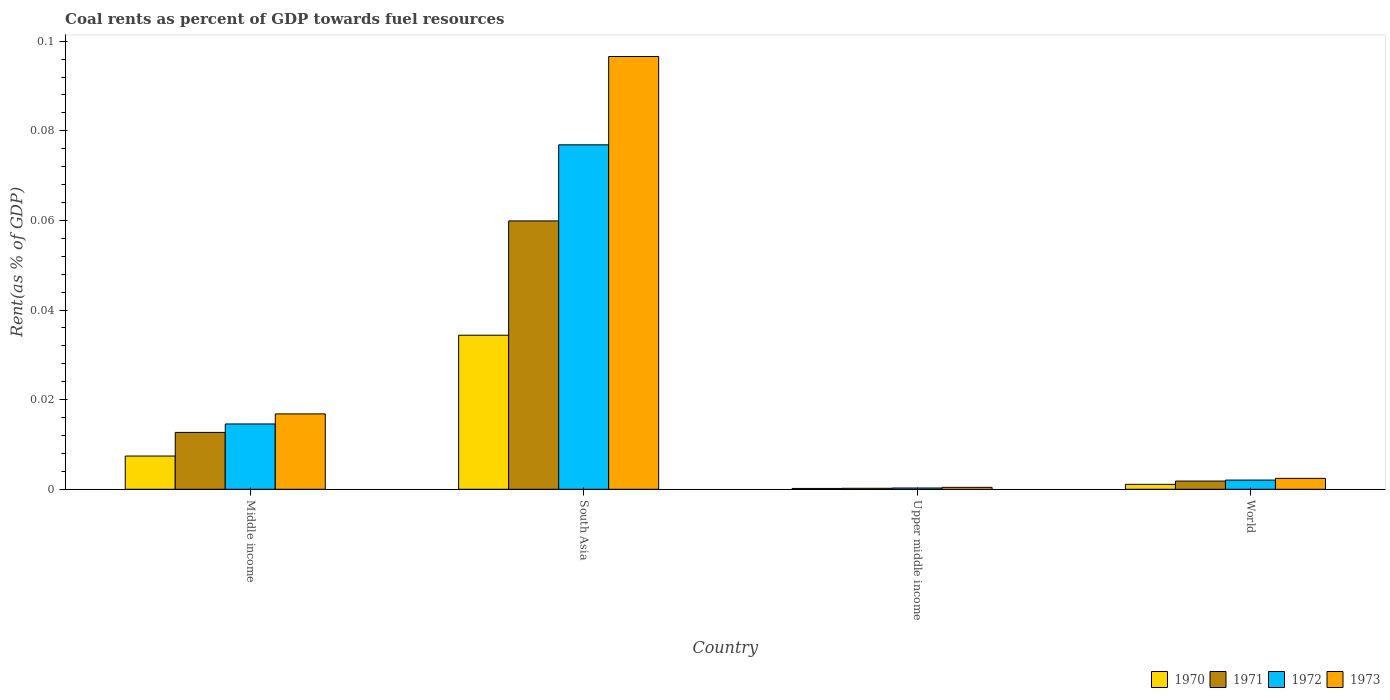How many different coloured bars are there?
Your answer should be compact. 4. Are the number of bars per tick equal to the number of legend labels?
Keep it short and to the point. Yes. In how many cases, is the number of bars for a given country not equal to the number of legend labels?
Your answer should be compact. 0. What is the coal rent in 1970 in South Asia?
Give a very brief answer. 0.03. Across all countries, what is the maximum coal rent in 1973?
Offer a terse response. 0.1. Across all countries, what is the minimum coal rent in 1973?
Your answer should be compact. 0. In which country was the coal rent in 1970 minimum?
Offer a terse response. Upper middle income. What is the total coal rent in 1971 in the graph?
Provide a succinct answer. 0.07. What is the difference between the coal rent in 1973 in South Asia and that in Upper middle income?
Ensure brevity in your answer.  0.1. What is the difference between the coal rent in 1971 in Upper middle income and the coal rent in 1970 in South Asia?
Keep it short and to the point. -0.03. What is the average coal rent in 1970 per country?
Offer a terse response. 0.01. What is the difference between the coal rent of/in 1970 and coal rent of/in 1972 in South Asia?
Provide a short and direct response. -0.04. What is the ratio of the coal rent in 1971 in Middle income to that in World?
Offer a terse response. 6.93. Is the difference between the coal rent in 1970 in South Asia and Upper middle income greater than the difference between the coal rent in 1972 in South Asia and Upper middle income?
Give a very brief answer. No. What is the difference between the highest and the second highest coal rent in 1972?
Give a very brief answer. 0.07. What is the difference between the highest and the lowest coal rent in 1970?
Your answer should be very brief. 0.03. What does the 1st bar from the left in Middle income represents?
Your answer should be very brief. 1970. What does the 3rd bar from the right in South Asia represents?
Give a very brief answer. 1971. Is it the case that in every country, the sum of the coal rent in 1971 and coal rent in 1972 is greater than the coal rent in 1970?
Offer a very short reply. Yes. How many bars are there?
Provide a succinct answer. 16. How many countries are there in the graph?
Give a very brief answer. 4. What is the difference between two consecutive major ticks on the Y-axis?
Offer a terse response. 0.02. Does the graph contain grids?
Ensure brevity in your answer.  No. Where does the legend appear in the graph?
Offer a very short reply. Bottom right. How are the legend labels stacked?
Your answer should be very brief. Horizontal. What is the title of the graph?
Offer a very short reply. Coal rents as percent of GDP towards fuel resources. Does "1971" appear as one of the legend labels in the graph?
Make the answer very short. Yes. What is the label or title of the Y-axis?
Keep it short and to the point. Rent(as % of GDP). What is the Rent(as % of GDP) of 1970 in Middle income?
Ensure brevity in your answer.  0.01. What is the Rent(as % of GDP) in 1971 in Middle income?
Make the answer very short. 0.01. What is the Rent(as % of GDP) of 1972 in Middle income?
Give a very brief answer. 0.01. What is the Rent(as % of GDP) in 1973 in Middle income?
Give a very brief answer. 0.02. What is the Rent(as % of GDP) of 1970 in South Asia?
Provide a short and direct response. 0.03. What is the Rent(as % of GDP) of 1971 in South Asia?
Offer a terse response. 0.06. What is the Rent(as % of GDP) in 1972 in South Asia?
Give a very brief answer. 0.08. What is the Rent(as % of GDP) of 1973 in South Asia?
Make the answer very short. 0.1. What is the Rent(as % of GDP) in 1970 in Upper middle income?
Your response must be concise. 0. What is the Rent(as % of GDP) of 1971 in Upper middle income?
Provide a short and direct response. 0. What is the Rent(as % of GDP) of 1972 in Upper middle income?
Provide a succinct answer. 0. What is the Rent(as % of GDP) in 1973 in Upper middle income?
Your answer should be very brief. 0. What is the Rent(as % of GDP) in 1970 in World?
Ensure brevity in your answer.  0. What is the Rent(as % of GDP) in 1971 in World?
Your answer should be very brief. 0. What is the Rent(as % of GDP) in 1972 in World?
Your response must be concise. 0. What is the Rent(as % of GDP) of 1973 in World?
Offer a very short reply. 0. Across all countries, what is the maximum Rent(as % of GDP) in 1970?
Give a very brief answer. 0.03. Across all countries, what is the maximum Rent(as % of GDP) in 1971?
Provide a short and direct response. 0.06. Across all countries, what is the maximum Rent(as % of GDP) of 1972?
Make the answer very short. 0.08. Across all countries, what is the maximum Rent(as % of GDP) in 1973?
Your answer should be compact. 0.1. Across all countries, what is the minimum Rent(as % of GDP) in 1970?
Offer a terse response. 0. Across all countries, what is the minimum Rent(as % of GDP) in 1971?
Your answer should be compact. 0. Across all countries, what is the minimum Rent(as % of GDP) in 1972?
Make the answer very short. 0. Across all countries, what is the minimum Rent(as % of GDP) in 1973?
Keep it short and to the point. 0. What is the total Rent(as % of GDP) in 1970 in the graph?
Provide a succinct answer. 0.04. What is the total Rent(as % of GDP) of 1971 in the graph?
Offer a terse response. 0.07. What is the total Rent(as % of GDP) of 1972 in the graph?
Offer a very short reply. 0.09. What is the total Rent(as % of GDP) of 1973 in the graph?
Offer a very short reply. 0.12. What is the difference between the Rent(as % of GDP) in 1970 in Middle income and that in South Asia?
Keep it short and to the point. -0.03. What is the difference between the Rent(as % of GDP) in 1971 in Middle income and that in South Asia?
Provide a succinct answer. -0.05. What is the difference between the Rent(as % of GDP) in 1972 in Middle income and that in South Asia?
Your answer should be compact. -0.06. What is the difference between the Rent(as % of GDP) of 1973 in Middle income and that in South Asia?
Keep it short and to the point. -0.08. What is the difference between the Rent(as % of GDP) in 1970 in Middle income and that in Upper middle income?
Your answer should be very brief. 0.01. What is the difference between the Rent(as % of GDP) of 1971 in Middle income and that in Upper middle income?
Your response must be concise. 0.01. What is the difference between the Rent(as % of GDP) in 1972 in Middle income and that in Upper middle income?
Make the answer very short. 0.01. What is the difference between the Rent(as % of GDP) in 1973 in Middle income and that in Upper middle income?
Provide a short and direct response. 0.02. What is the difference between the Rent(as % of GDP) in 1970 in Middle income and that in World?
Your response must be concise. 0.01. What is the difference between the Rent(as % of GDP) of 1971 in Middle income and that in World?
Your answer should be very brief. 0.01. What is the difference between the Rent(as % of GDP) of 1972 in Middle income and that in World?
Provide a short and direct response. 0.01. What is the difference between the Rent(as % of GDP) of 1973 in Middle income and that in World?
Give a very brief answer. 0.01. What is the difference between the Rent(as % of GDP) of 1970 in South Asia and that in Upper middle income?
Your answer should be compact. 0.03. What is the difference between the Rent(as % of GDP) of 1971 in South Asia and that in Upper middle income?
Make the answer very short. 0.06. What is the difference between the Rent(as % of GDP) of 1972 in South Asia and that in Upper middle income?
Provide a short and direct response. 0.08. What is the difference between the Rent(as % of GDP) of 1973 in South Asia and that in Upper middle income?
Your answer should be very brief. 0.1. What is the difference between the Rent(as % of GDP) in 1970 in South Asia and that in World?
Keep it short and to the point. 0.03. What is the difference between the Rent(as % of GDP) of 1971 in South Asia and that in World?
Offer a terse response. 0.06. What is the difference between the Rent(as % of GDP) in 1972 in South Asia and that in World?
Make the answer very short. 0.07. What is the difference between the Rent(as % of GDP) of 1973 in South Asia and that in World?
Keep it short and to the point. 0.09. What is the difference between the Rent(as % of GDP) of 1970 in Upper middle income and that in World?
Offer a terse response. -0. What is the difference between the Rent(as % of GDP) of 1971 in Upper middle income and that in World?
Your answer should be compact. -0. What is the difference between the Rent(as % of GDP) in 1972 in Upper middle income and that in World?
Make the answer very short. -0. What is the difference between the Rent(as % of GDP) of 1973 in Upper middle income and that in World?
Give a very brief answer. -0. What is the difference between the Rent(as % of GDP) in 1970 in Middle income and the Rent(as % of GDP) in 1971 in South Asia?
Provide a short and direct response. -0.05. What is the difference between the Rent(as % of GDP) of 1970 in Middle income and the Rent(as % of GDP) of 1972 in South Asia?
Provide a succinct answer. -0.07. What is the difference between the Rent(as % of GDP) of 1970 in Middle income and the Rent(as % of GDP) of 1973 in South Asia?
Provide a short and direct response. -0.09. What is the difference between the Rent(as % of GDP) of 1971 in Middle income and the Rent(as % of GDP) of 1972 in South Asia?
Your answer should be very brief. -0.06. What is the difference between the Rent(as % of GDP) of 1971 in Middle income and the Rent(as % of GDP) of 1973 in South Asia?
Offer a terse response. -0.08. What is the difference between the Rent(as % of GDP) of 1972 in Middle income and the Rent(as % of GDP) of 1973 in South Asia?
Offer a very short reply. -0.08. What is the difference between the Rent(as % of GDP) in 1970 in Middle income and the Rent(as % of GDP) in 1971 in Upper middle income?
Provide a short and direct response. 0.01. What is the difference between the Rent(as % of GDP) in 1970 in Middle income and the Rent(as % of GDP) in 1972 in Upper middle income?
Provide a succinct answer. 0.01. What is the difference between the Rent(as % of GDP) of 1970 in Middle income and the Rent(as % of GDP) of 1973 in Upper middle income?
Offer a terse response. 0.01. What is the difference between the Rent(as % of GDP) in 1971 in Middle income and the Rent(as % of GDP) in 1972 in Upper middle income?
Make the answer very short. 0.01. What is the difference between the Rent(as % of GDP) of 1971 in Middle income and the Rent(as % of GDP) of 1973 in Upper middle income?
Give a very brief answer. 0.01. What is the difference between the Rent(as % of GDP) in 1972 in Middle income and the Rent(as % of GDP) in 1973 in Upper middle income?
Offer a very short reply. 0.01. What is the difference between the Rent(as % of GDP) in 1970 in Middle income and the Rent(as % of GDP) in 1971 in World?
Give a very brief answer. 0.01. What is the difference between the Rent(as % of GDP) in 1970 in Middle income and the Rent(as % of GDP) in 1972 in World?
Make the answer very short. 0.01. What is the difference between the Rent(as % of GDP) of 1970 in Middle income and the Rent(as % of GDP) of 1973 in World?
Your response must be concise. 0.01. What is the difference between the Rent(as % of GDP) in 1971 in Middle income and the Rent(as % of GDP) in 1972 in World?
Provide a succinct answer. 0.01. What is the difference between the Rent(as % of GDP) of 1971 in Middle income and the Rent(as % of GDP) of 1973 in World?
Provide a succinct answer. 0.01. What is the difference between the Rent(as % of GDP) in 1972 in Middle income and the Rent(as % of GDP) in 1973 in World?
Offer a terse response. 0.01. What is the difference between the Rent(as % of GDP) in 1970 in South Asia and the Rent(as % of GDP) in 1971 in Upper middle income?
Make the answer very short. 0.03. What is the difference between the Rent(as % of GDP) of 1970 in South Asia and the Rent(as % of GDP) of 1972 in Upper middle income?
Provide a succinct answer. 0.03. What is the difference between the Rent(as % of GDP) of 1970 in South Asia and the Rent(as % of GDP) of 1973 in Upper middle income?
Make the answer very short. 0.03. What is the difference between the Rent(as % of GDP) in 1971 in South Asia and the Rent(as % of GDP) in 1972 in Upper middle income?
Your answer should be very brief. 0.06. What is the difference between the Rent(as % of GDP) in 1971 in South Asia and the Rent(as % of GDP) in 1973 in Upper middle income?
Offer a terse response. 0.06. What is the difference between the Rent(as % of GDP) of 1972 in South Asia and the Rent(as % of GDP) of 1973 in Upper middle income?
Your response must be concise. 0.08. What is the difference between the Rent(as % of GDP) in 1970 in South Asia and the Rent(as % of GDP) in 1971 in World?
Offer a terse response. 0.03. What is the difference between the Rent(as % of GDP) in 1970 in South Asia and the Rent(as % of GDP) in 1972 in World?
Offer a terse response. 0.03. What is the difference between the Rent(as % of GDP) of 1970 in South Asia and the Rent(as % of GDP) of 1973 in World?
Offer a terse response. 0.03. What is the difference between the Rent(as % of GDP) in 1971 in South Asia and the Rent(as % of GDP) in 1972 in World?
Offer a very short reply. 0.06. What is the difference between the Rent(as % of GDP) in 1971 in South Asia and the Rent(as % of GDP) in 1973 in World?
Provide a short and direct response. 0.06. What is the difference between the Rent(as % of GDP) in 1972 in South Asia and the Rent(as % of GDP) in 1973 in World?
Offer a very short reply. 0.07. What is the difference between the Rent(as % of GDP) in 1970 in Upper middle income and the Rent(as % of GDP) in 1971 in World?
Offer a very short reply. -0. What is the difference between the Rent(as % of GDP) in 1970 in Upper middle income and the Rent(as % of GDP) in 1972 in World?
Give a very brief answer. -0. What is the difference between the Rent(as % of GDP) of 1970 in Upper middle income and the Rent(as % of GDP) of 1973 in World?
Provide a short and direct response. -0. What is the difference between the Rent(as % of GDP) of 1971 in Upper middle income and the Rent(as % of GDP) of 1972 in World?
Give a very brief answer. -0. What is the difference between the Rent(as % of GDP) of 1971 in Upper middle income and the Rent(as % of GDP) of 1973 in World?
Give a very brief answer. -0. What is the difference between the Rent(as % of GDP) of 1972 in Upper middle income and the Rent(as % of GDP) of 1973 in World?
Offer a very short reply. -0. What is the average Rent(as % of GDP) of 1970 per country?
Your answer should be very brief. 0.01. What is the average Rent(as % of GDP) in 1971 per country?
Offer a terse response. 0.02. What is the average Rent(as % of GDP) in 1972 per country?
Provide a short and direct response. 0.02. What is the average Rent(as % of GDP) of 1973 per country?
Ensure brevity in your answer.  0.03. What is the difference between the Rent(as % of GDP) in 1970 and Rent(as % of GDP) in 1971 in Middle income?
Ensure brevity in your answer.  -0.01. What is the difference between the Rent(as % of GDP) in 1970 and Rent(as % of GDP) in 1972 in Middle income?
Provide a succinct answer. -0.01. What is the difference between the Rent(as % of GDP) in 1970 and Rent(as % of GDP) in 1973 in Middle income?
Provide a succinct answer. -0.01. What is the difference between the Rent(as % of GDP) in 1971 and Rent(as % of GDP) in 1972 in Middle income?
Keep it short and to the point. -0. What is the difference between the Rent(as % of GDP) in 1971 and Rent(as % of GDP) in 1973 in Middle income?
Give a very brief answer. -0. What is the difference between the Rent(as % of GDP) of 1972 and Rent(as % of GDP) of 1973 in Middle income?
Your response must be concise. -0. What is the difference between the Rent(as % of GDP) of 1970 and Rent(as % of GDP) of 1971 in South Asia?
Your response must be concise. -0.03. What is the difference between the Rent(as % of GDP) of 1970 and Rent(as % of GDP) of 1972 in South Asia?
Your answer should be very brief. -0.04. What is the difference between the Rent(as % of GDP) of 1970 and Rent(as % of GDP) of 1973 in South Asia?
Keep it short and to the point. -0.06. What is the difference between the Rent(as % of GDP) of 1971 and Rent(as % of GDP) of 1972 in South Asia?
Ensure brevity in your answer.  -0.02. What is the difference between the Rent(as % of GDP) in 1971 and Rent(as % of GDP) in 1973 in South Asia?
Your answer should be very brief. -0.04. What is the difference between the Rent(as % of GDP) in 1972 and Rent(as % of GDP) in 1973 in South Asia?
Keep it short and to the point. -0.02. What is the difference between the Rent(as % of GDP) in 1970 and Rent(as % of GDP) in 1971 in Upper middle income?
Give a very brief answer. -0. What is the difference between the Rent(as % of GDP) in 1970 and Rent(as % of GDP) in 1972 in Upper middle income?
Keep it short and to the point. -0. What is the difference between the Rent(as % of GDP) in 1970 and Rent(as % of GDP) in 1973 in Upper middle income?
Give a very brief answer. -0. What is the difference between the Rent(as % of GDP) in 1971 and Rent(as % of GDP) in 1972 in Upper middle income?
Keep it short and to the point. -0. What is the difference between the Rent(as % of GDP) of 1971 and Rent(as % of GDP) of 1973 in Upper middle income?
Your answer should be very brief. -0. What is the difference between the Rent(as % of GDP) of 1972 and Rent(as % of GDP) of 1973 in Upper middle income?
Ensure brevity in your answer.  -0. What is the difference between the Rent(as % of GDP) of 1970 and Rent(as % of GDP) of 1971 in World?
Offer a very short reply. -0. What is the difference between the Rent(as % of GDP) of 1970 and Rent(as % of GDP) of 1972 in World?
Provide a short and direct response. -0. What is the difference between the Rent(as % of GDP) of 1970 and Rent(as % of GDP) of 1973 in World?
Your response must be concise. -0. What is the difference between the Rent(as % of GDP) in 1971 and Rent(as % of GDP) in 1972 in World?
Your response must be concise. -0. What is the difference between the Rent(as % of GDP) of 1971 and Rent(as % of GDP) of 1973 in World?
Offer a terse response. -0. What is the difference between the Rent(as % of GDP) of 1972 and Rent(as % of GDP) of 1973 in World?
Your answer should be very brief. -0. What is the ratio of the Rent(as % of GDP) in 1970 in Middle income to that in South Asia?
Your response must be concise. 0.22. What is the ratio of the Rent(as % of GDP) in 1971 in Middle income to that in South Asia?
Provide a short and direct response. 0.21. What is the ratio of the Rent(as % of GDP) in 1972 in Middle income to that in South Asia?
Your response must be concise. 0.19. What is the ratio of the Rent(as % of GDP) in 1973 in Middle income to that in South Asia?
Ensure brevity in your answer.  0.17. What is the ratio of the Rent(as % of GDP) in 1970 in Middle income to that in Upper middle income?
Keep it short and to the point. 40.36. What is the ratio of the Rent(as % of GDP) in 1971 in Middle income to that in Upper middle income?
Offer a terse response. 58.01. What is the ratio of the Rent(as % of GDP) of 1972 in Middle income to that in Upper middle income?
Make the answer very short. 51.25. What is the ratio of the Rent(as % of GDP) of 1973 in Middle income to that in Upper middle income?
Your answer should be compact. 39.04. What is the ratio of the Rent(as % of GDP) in 1970 in Middle income to that in World?
Ensure brevity in your answer.  6.74. What is the ratio of the Rent(as % of GDP) of 1971 in Middle income to that in World?
Your response must be concise. 6.93. What is the ratio of the Rent(as % of GDP) of 1972 in Middle income to that in World?
Give a very brief answer. 7.09. What is the ratio of the Rent(as % of GDP) in 1973 in Middle income to that in World?
Offer a very short reply. 6.91. What is the ratio of the Rent(as % of GDP) of 1970 in South Asia to that in Upper middle income?
Keep it short and to the point. 187.05. What is the ratio of the Rent(as % of GDP) in 1971 in South Asia to that in Upper middle income?
Your answer should be very brief. 273.74. What is the ratio of the Rent(as % of GDP) in 1972 in South Asia to that in Upper middle income?
Provide a short and direct response. 270.32. What is the ratio of the Rent(as % of GDP) in 1973 in South Asia to that in Upper middle income?
Offer a very short reply. 224.18. What is the ratio of the Rent(as % of GDP) in 1970 in South Asia to that in World?
Keep it short and to the point. 31.24. What is the ratio of the Rent(as % of GDP) of 1971 in South Asia to that in World?
Give a very brief answer. 32.69. What is the ratio of the Rent(as % of GDP) in 1972 in South Asia to that in World?
Offer a terse response. 37.41. What is the ratio of the Rent(as % of GDP) of 1973 in South Asia to that in World?
Provide a short and direct response. 39.65. What is the ratio of the Rent(as % of GDP) of 1970 in Upper middle income to that in World?
Make the answer very short. 0.17. What is the ratio of the Rent(as % of GDP) in 1971 in Upper middle income to that in World?
Offer a terse response. 0.12. What is the ratio of the Rent(as % of GDP) in 1972 in Upper middle income to that in World?
Keep it short and to the point. 0.14. What is the ratio of the Rent(as % of GDP) of 1973 in Upper middle income to that in World?
Provide a short and direct response. 0.18. What is the difference between the highest and the second highest Rent(as % of GDP) of 1970?
Your answer should be very brief. 0.03. What is the difference between the highest and the second highest Rent(as % of GDP) in 1971?
Give a very brief answer. 0.05. What is the difference between the highest and the second highest Rent(as % of GDP) in 1972?
Ensure brevity in your answer.  0.06. What is the difference between the highest and the second highest Rent(as % of GDP) of 1973?
Your response must be concise. 0.08. What is the difference between the highest and the lowest Rent(as % of GDP) of 1970?
Provide a succinct answer. 0.03. What is the difference between the highest and the lowest Rent(as % of GDP) of 1971?
Offer a very short reply. 0.06. What is the difference between the highest and the lowest Rent(as % of GDP) in 1972?
Your response must be concise. 0.08. What is the difference between the highest and the lowest Rent(as % of GDP) in 1973?
Offer a terse response. 0.1. 